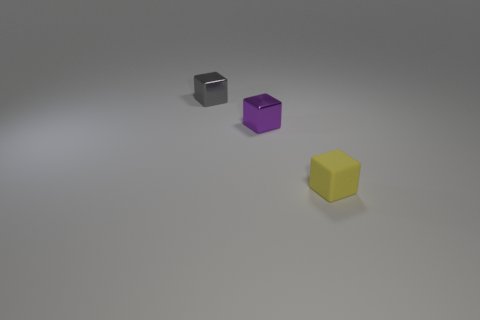How many objects are in the image, and can you describe them? There are three objects in the image. From left to right, there’s a small black cube with a reflective surface, a slightly larger purple cube with a shiny finish, and a larger yellow cube with a matte appearance. 